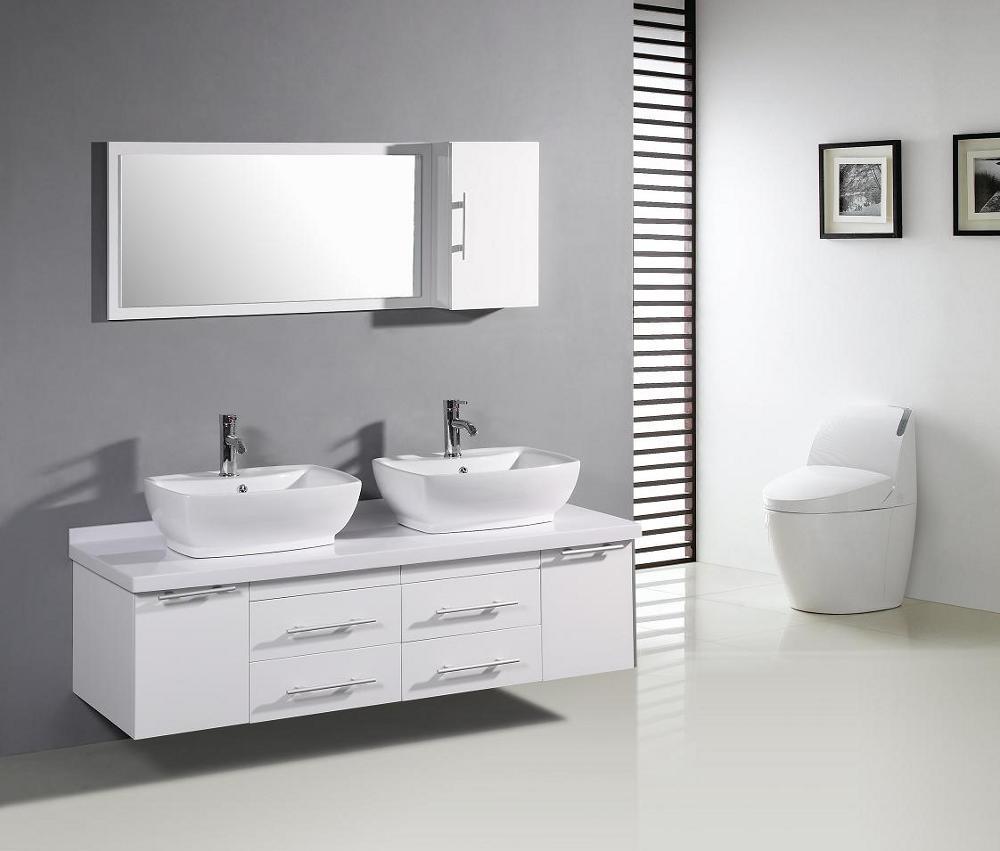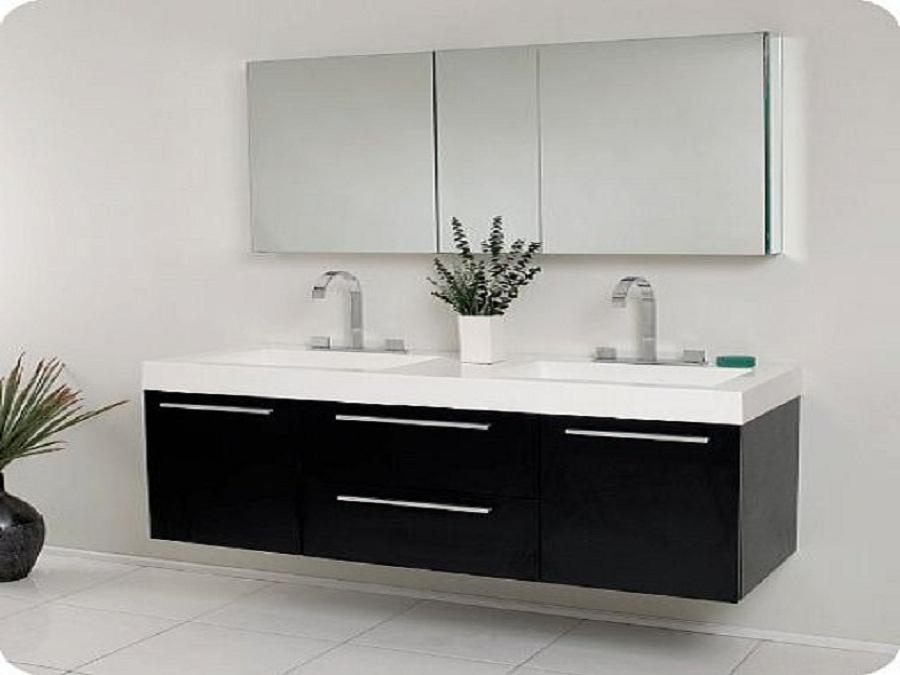The first image is the image on the left, the second image is the image on the right. Assess this claim about the two images: "An image shows a white rectangular sink with two separate faucets.". Correct or not? Answer yes or no. Yes. The first image is the image on the left, the second image is the image on the right. For the images shown, is this caption "The counter in the image on the right is white on a black cabinet." true? Answer yes or no. Yes. 